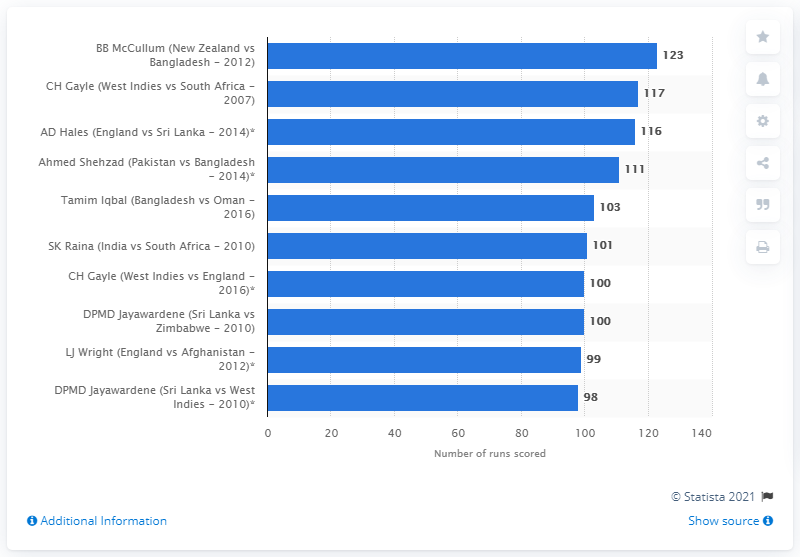Mention a couple of crucial points in this snapshot. During the 2012 T20 World Cup, the record score against Bangladesh was 123. 